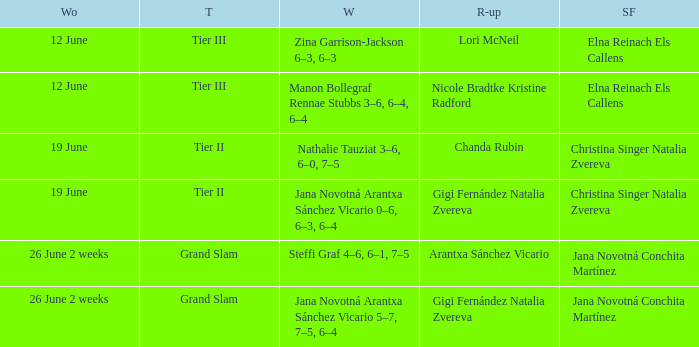Who are the semi finalists on the week of 12 june, when the runner-up is listed as Lori McNeil? Elna Reinach Els Callens. 